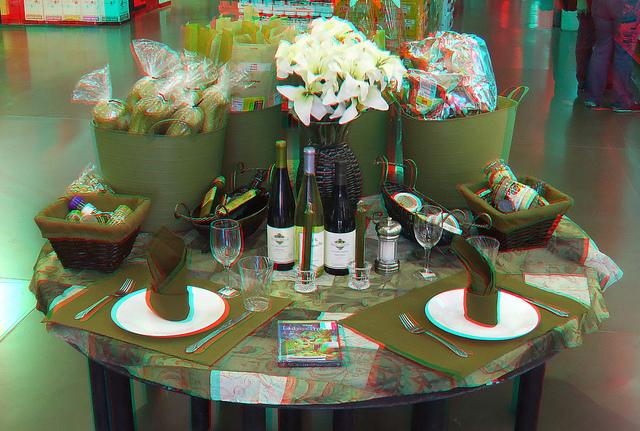What are the primary colors appearing in the picture?
Short answer required. Green. Was this picture taken out of focus?
Write a very short answer. Yes. What type of plant is on the table?
Give a very brief answer. Flowers. Are there gift baskets in this photo?
Give a very brief answer. Yes. 